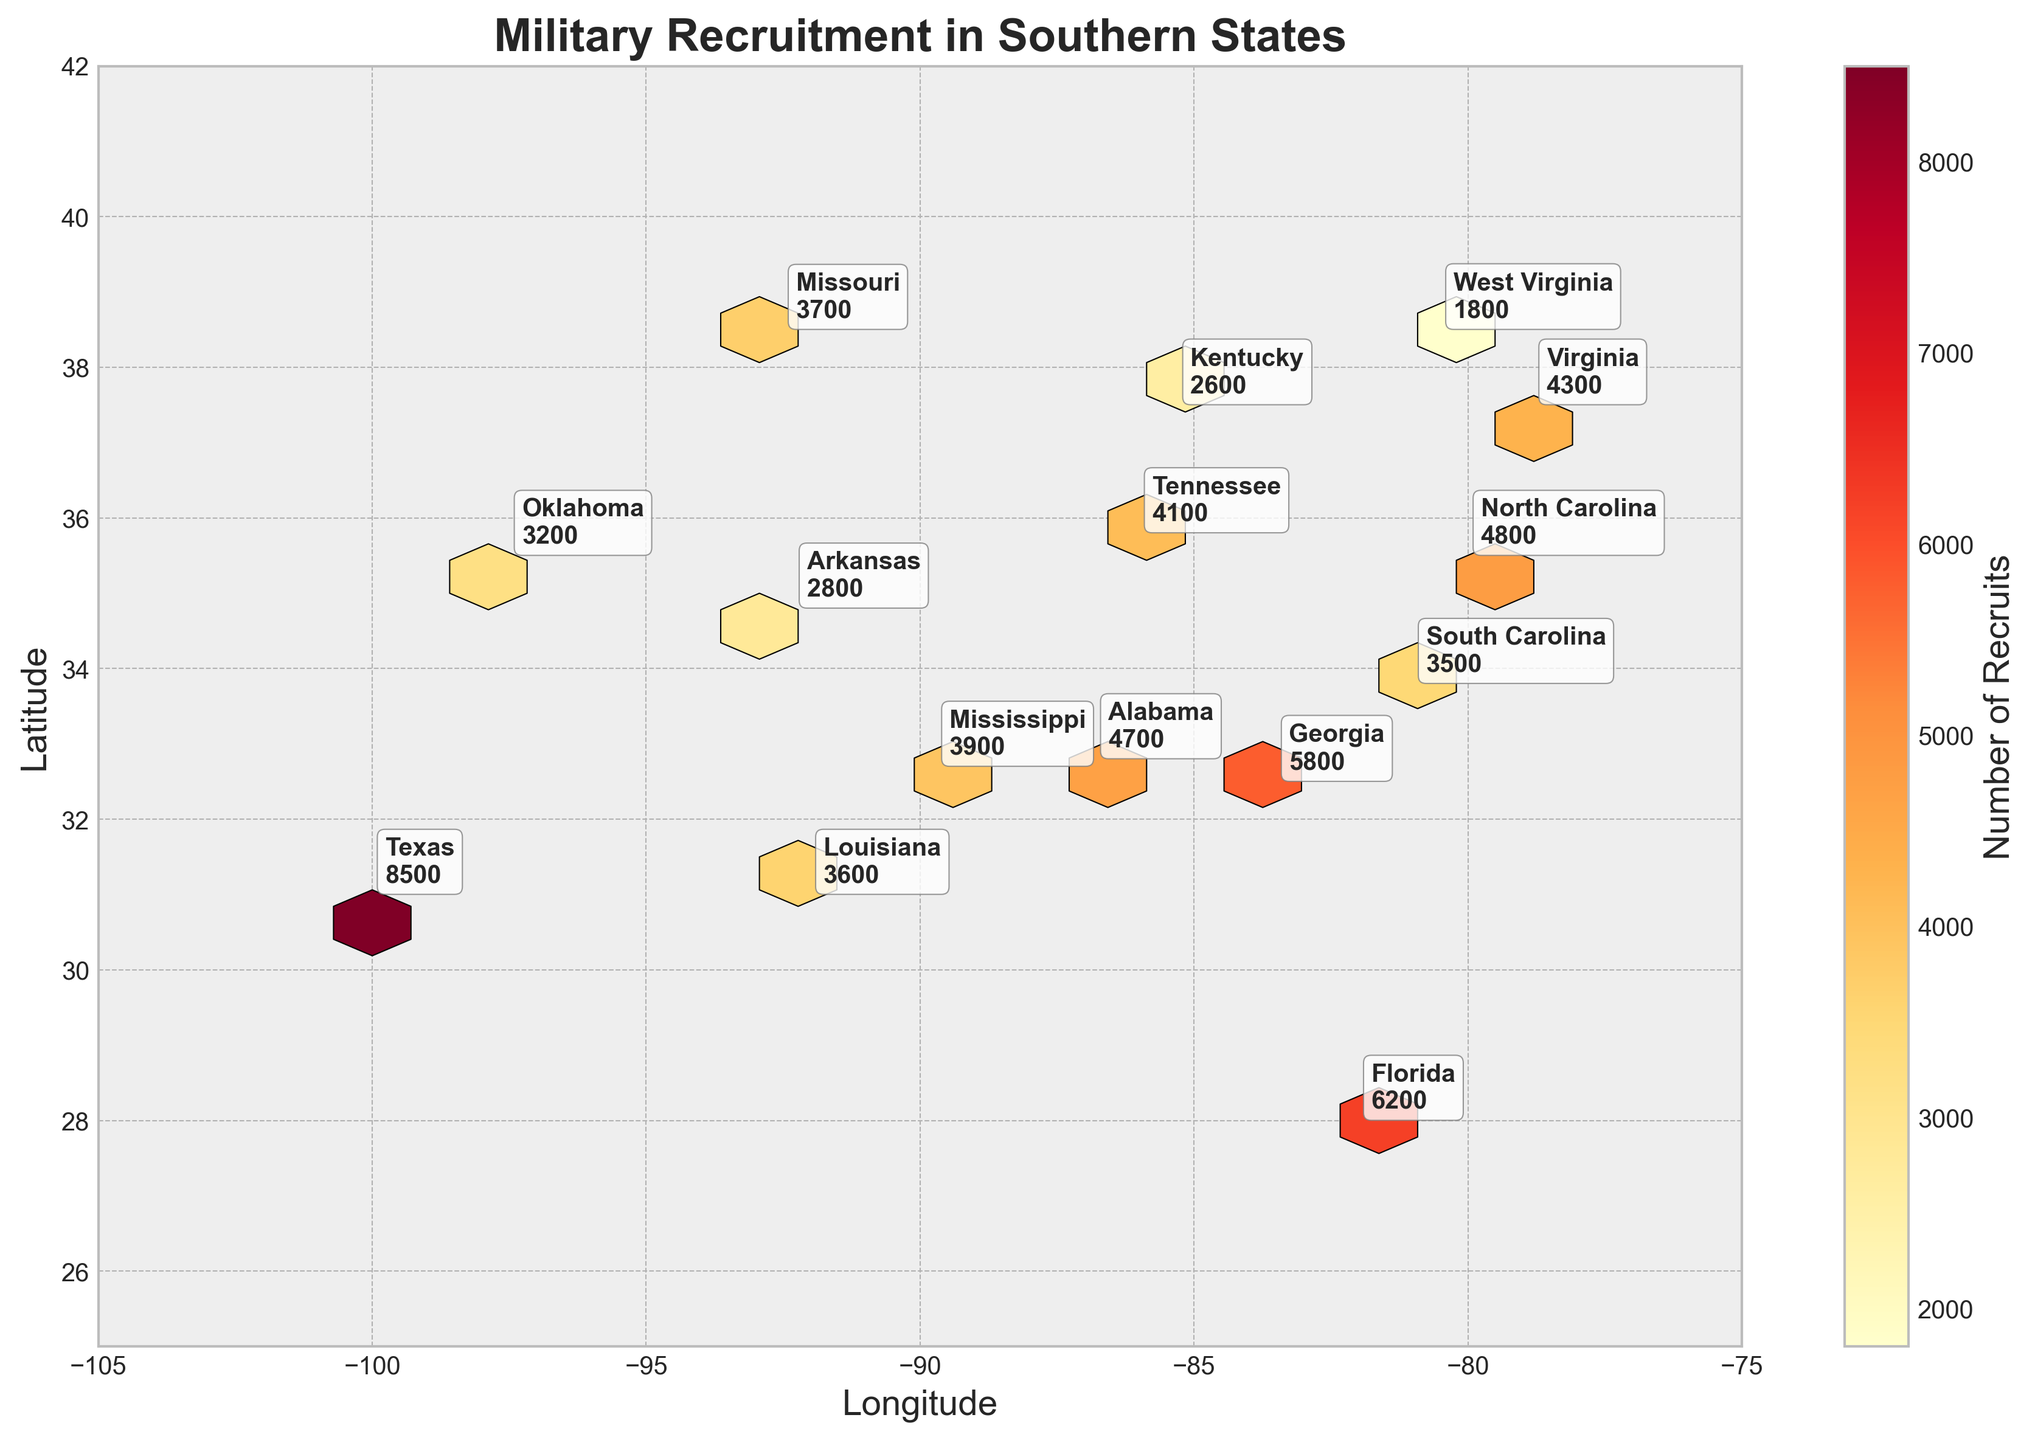What's the title of the plot? The title is prominently displayed at the top of the figure, indicating the focus of the data being visualized.
Answer: Military Recruitment in Southern States What is the range of latitude on the plot? The latitude range is indicated on the y-axis, stretching from the minimum to the maximum values shown.
Answer: 25 to 42 Which state has the highest number of recruits? The number of recruits is annotated next to each state on the plot. One must look for the highest number.
Answer: Texas What color represents areas with the highest recruitment numbers? The plot uses a color gradient. The color associated with the highest values is typically the most intense (brightest) in a hexbin plot.
Answer: Bright yellow How many states have more than 5,000 recruits? By checking each state's annotation, one counts how many have a value exceeding 5,000.
Answer: 3 (Texas, Florida, Georgia) Which states are closest to each other geographically? By cross-referencing the latitude and longitude annotations and their hexbin locations, one can determine which states are nearest on the plot.
Answer: Virginia and Kentucky What is the geographical range of longitude for this hexbin plot? The longitude range can be seen on the x-axis, specifying the boundaries of the plot.
Answer: -105 to -75 How do the number of recruits in Alabama compare to those in Mississippi? By reading the annotated number of recruits next to Alabama and Mississippi, one can compare these values.
Answer: Alabama (4700) is higher than Mississippi (3900) Which states lie within the longitude range of -80 to -90? Checking the annotated longitudes, locate the states whose longitudes fall between these values.
Answer: South Carolina, Florida, Alabama, and Mississippi 